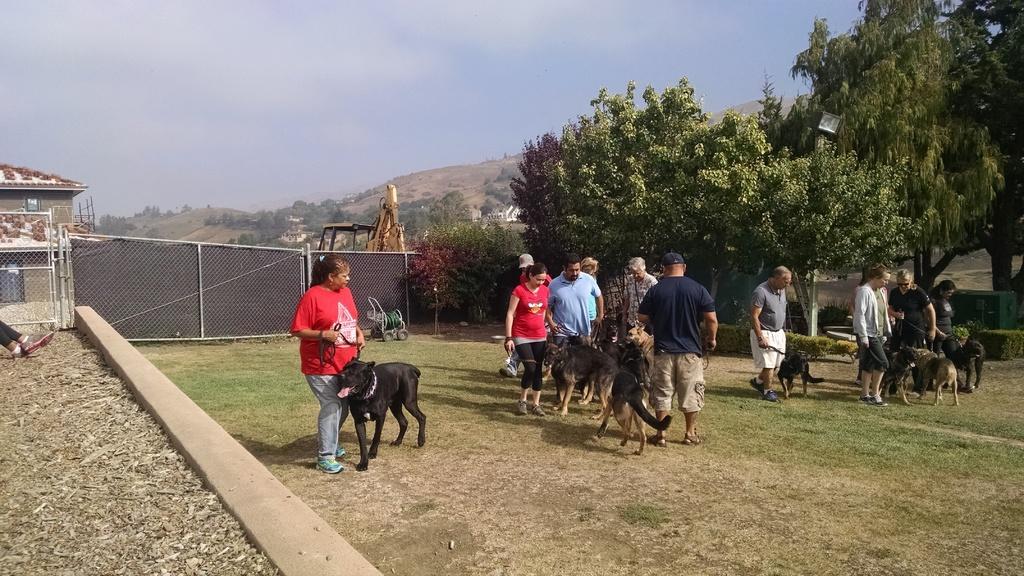How would you summarize this image in a sentence or two? In this image, we can see a group of people and dogs on the ground. Few people are holding belts. Background we can see plants, trees, mesh, rods, vehicles, houses, hills and sky. On the left side of the image, we can see the legs of a person. 